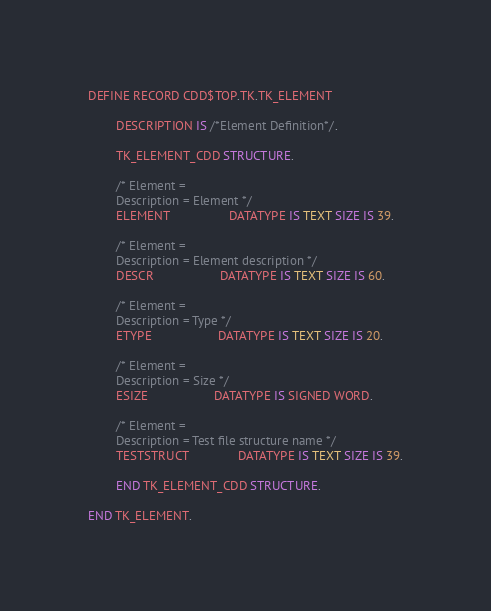<code> <loc_0><loc_0><loc_500><loc_500><_SQL_>DEFINE RECORD CDD$TOP.TK.TK_ELEMENT

        DESCRIPTION IS /*Element Definition*/.

        TK_ELEMENT_CDD STRUCTURE.

        /* Element =
        Description = Element */
        ELEMENT                 DATATYPE IS TEXT SIZE IS 39.

        /* Element =
        Description = Element description */
        DESCR                   DATATYPE IS TEXT SIZE IS 60.

        /* Element =
        Description = Type */
        ETYPE                   DATATYPE IS TEXT SIZE IS 20.

        /* Element =
        Description = Size */
        ESIZE                   DATATYPE IS SIGNED WORD.

        /* Element =
        Description = Test file structure name */
        TESTSTRUCT              DATATYPE IS TEXT SIZE IS 39.

        END TK_ELEMENT_CDD STRUCTURE.

END TK_ELEMENT.
</code> 